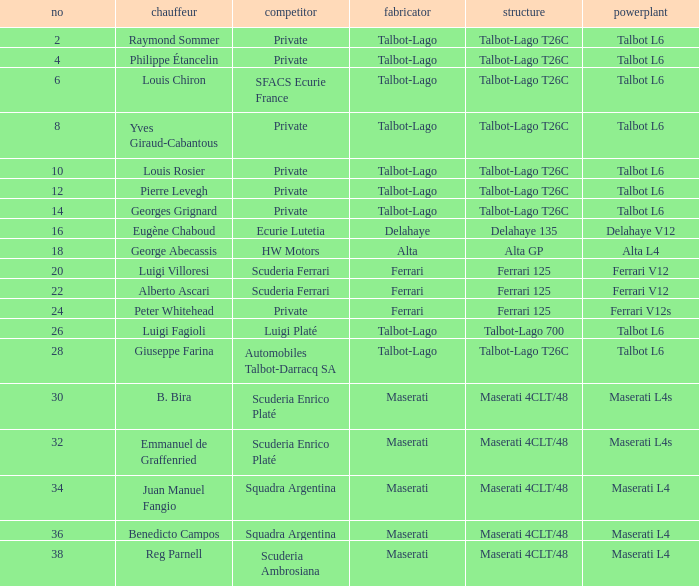Name the chassis for sfacs ecurie france Talbot-Lago T26C. 